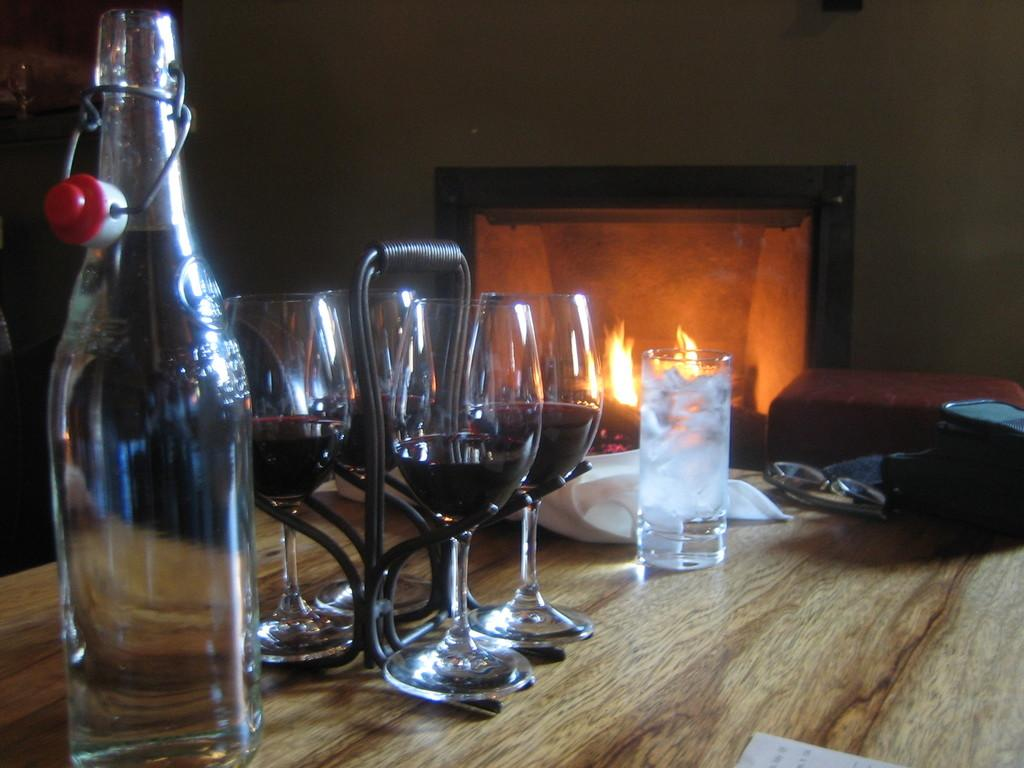What is the main piece of furniture in the image? There is a table in the image. What objects can be seen on the table? There are glasses, a bottle, a glass, and a bag on the table. Is there another table visible in the image? Yes, there is a table in the background. What can be seen in the background of the image? There is fire and a wall in the background. How many sheep are visible in the image? There are no sheep present in the image. Is there a zipper on any of the objects in the image? There is no zipper visible on any of the objects in the image. 